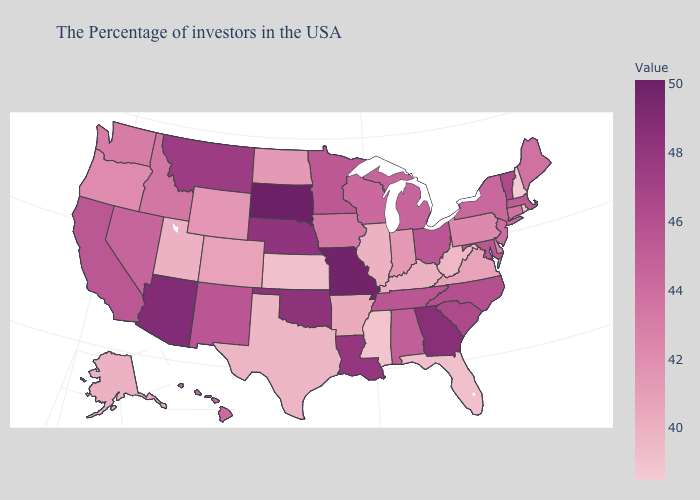Does Rhode Island have a higher value than Minnesota?
Give a very brief answer. No. Does New Hampshire have the lowest value in the Northeast?
Give a very brief answer. Yes. Among the states that border Arizona , does California have the highest value?
Write a very short answer. No. Among the states that border Virginia , which have the highest value?
Quick response, please. North Carolina. Does Iowa have the lowest value in the MidWest?
Be succinct. No. Which states have the lowest value in the USA?
Short answer required. New Hampshire. 